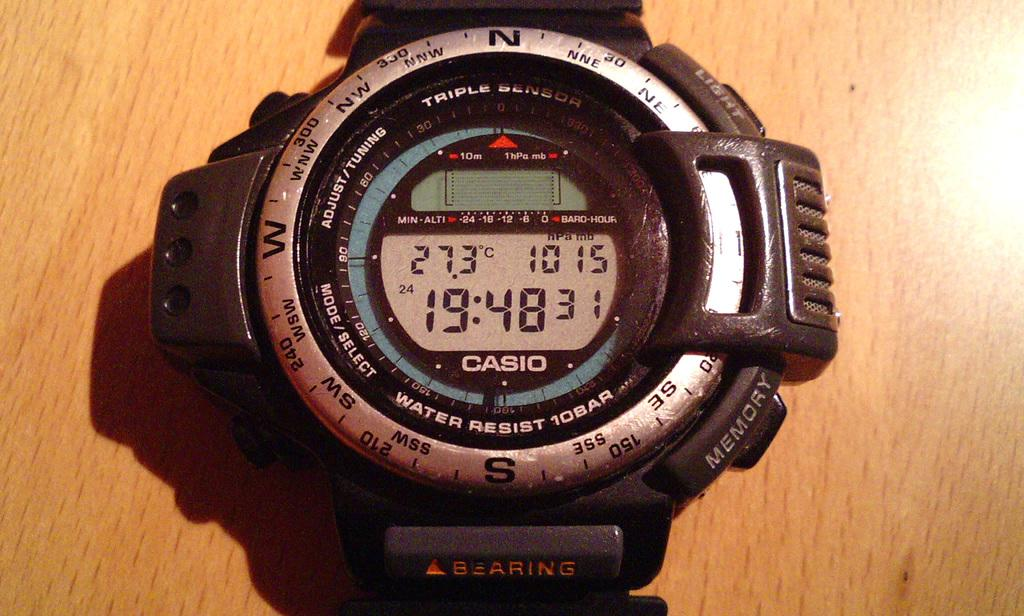<image>
Present a compact description of the photo's key features. A Casio watch on a wooden floor shows the time is 19:48. 